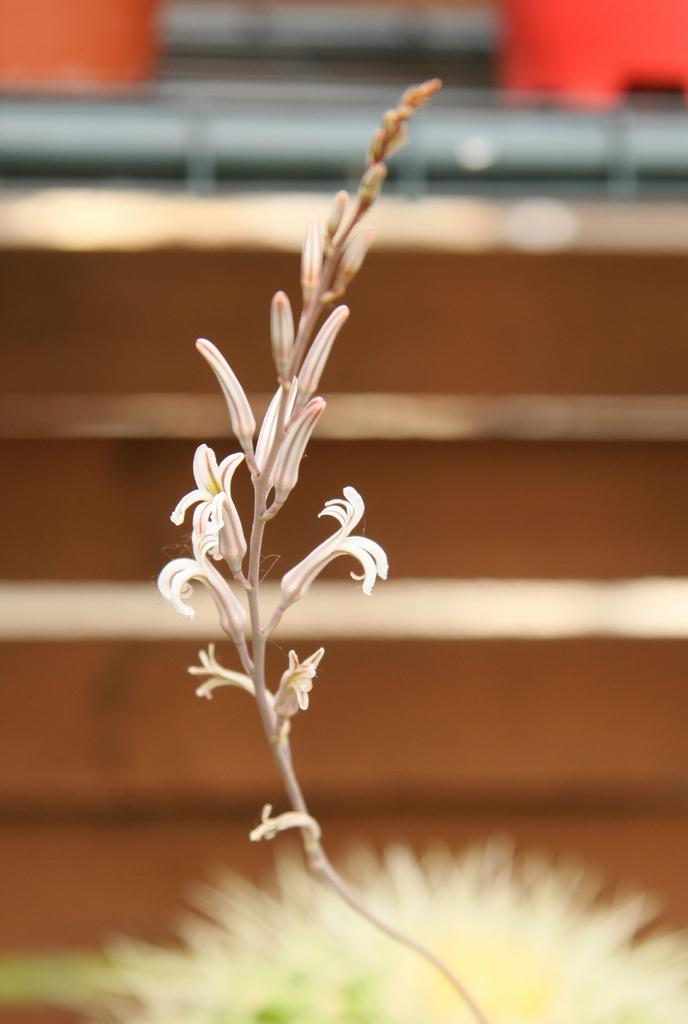What type of plants can be seen in the image? There are flowers in the image. Can you describe the stage of growth for some of the plants? There are buds in the image, which are at an early stage of growth. What is the appearance of the background in the image? The background of the image is blurred. What type of crime is being committed in the image? There is no crime present in the image; it features flowers and buds. What religious symbol can be seen in the image? There is no religious symbol present in the image; it features flowers and buds. 